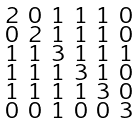<formula> <loc_0><loc_0><loc_500><loc_500>\begin{smallmatrix} 2 & 0 & 1 & 1 & 1 & 0 \\ 0 & 2 & 1 & 1 & 1 & 0 \\ 1 & 1 & 3 & 1 & 1 & 1 \\ 1 & 1 & 1 & 3 & 1 & 0 \\ 1 & 1 & 1 & 1 & 3 & 0 \\ 0 & 0 & 1 & 0 & 0 & 3 \end{smallmatrix}</formula> 